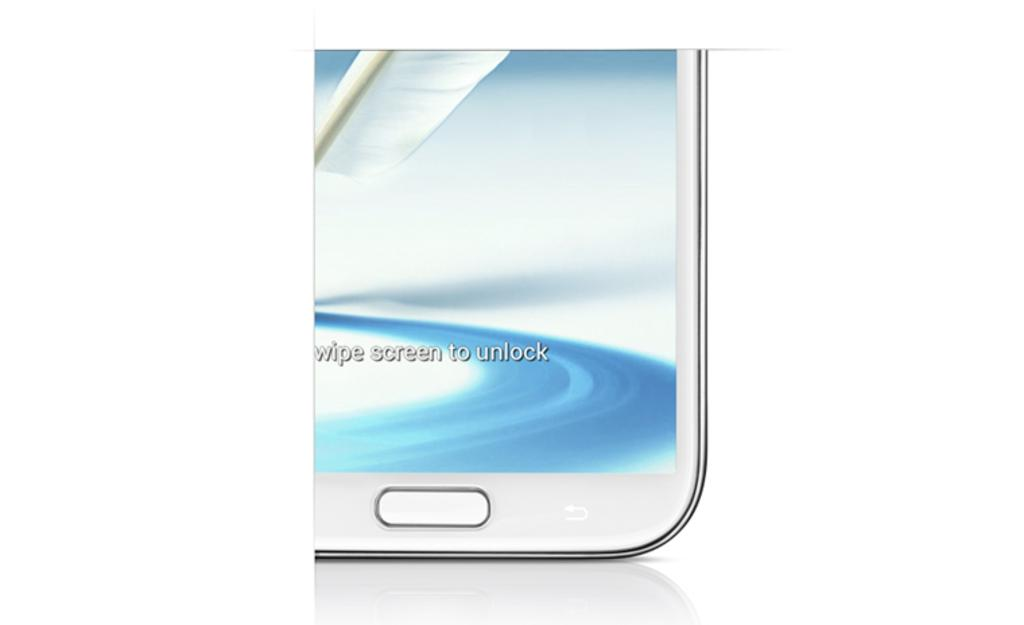<image>
Share a concise interpretation of the image provided. partial photo of a white phone showing message wipe screen to unlock 